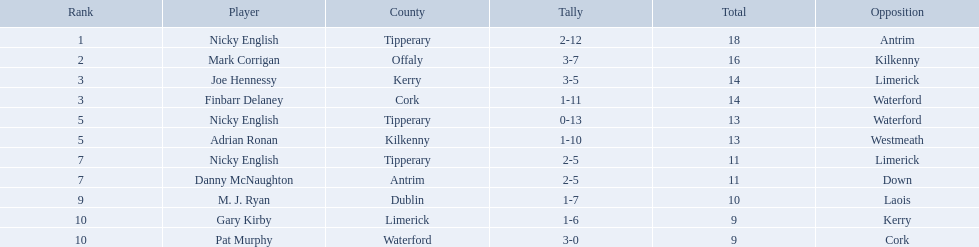Which of the following players were ranked in the bottom 5? Nicky English, Danny McNaughton, M. J. Ryan, Gary Kirby, Pat Murphy. Of these, whose tallies were not 2-5? M. J. Ryan, Gary Kirby, Pat Murphy. From the above three, which one scored more than 9 total points? M. J. Ryan. What figures are present in the total column? 18, 16, 14, 14, 13, 13, 11, 11, 10, 9, 9. Which row contains the number 10 in the total column? 9, M. J. Ryan, Dublin, 1-7, 10, Laois. What title is in the player column for this specific row? M. J. Ryan. What numerals are included in the total column? 18, 16, 14, 14, 13, 13, 11, 11, 10, 9, 9. In what row does the number 10 appear in the total column? 9, M. J. Ryan, Dublin, 1-7, 10, Laois. What label is in the player column for this individual row? M. J. Ryan. Among the listed players, who were in the lowest 5 ranks? Nicky English, Danny McNaughton, M. J. Ryan, Gary Kirby, Pat Murphy. Out of these, who did not have a score between 2 and 5? M. J. Ryan, Gary Kirby, Pat Murphy. From the mentioned three, who had a total score exceeding 9 points? M. J. Ryan. Who are all the participants? Nicky English, Mark Corrigan, Joe Hennessy, Finbarr Delaney, Nicky English, Adrian Ronan, Nicky English, Danny McNaughton, M. J. Ryan, Gary Kirby, Pat Murphy. What was the number of points they were awarded? 18, 16, 14, 14, 13, 13, 11, 11, 10, 9, 9. And who among them got 10 points? M. J. Ryan. 